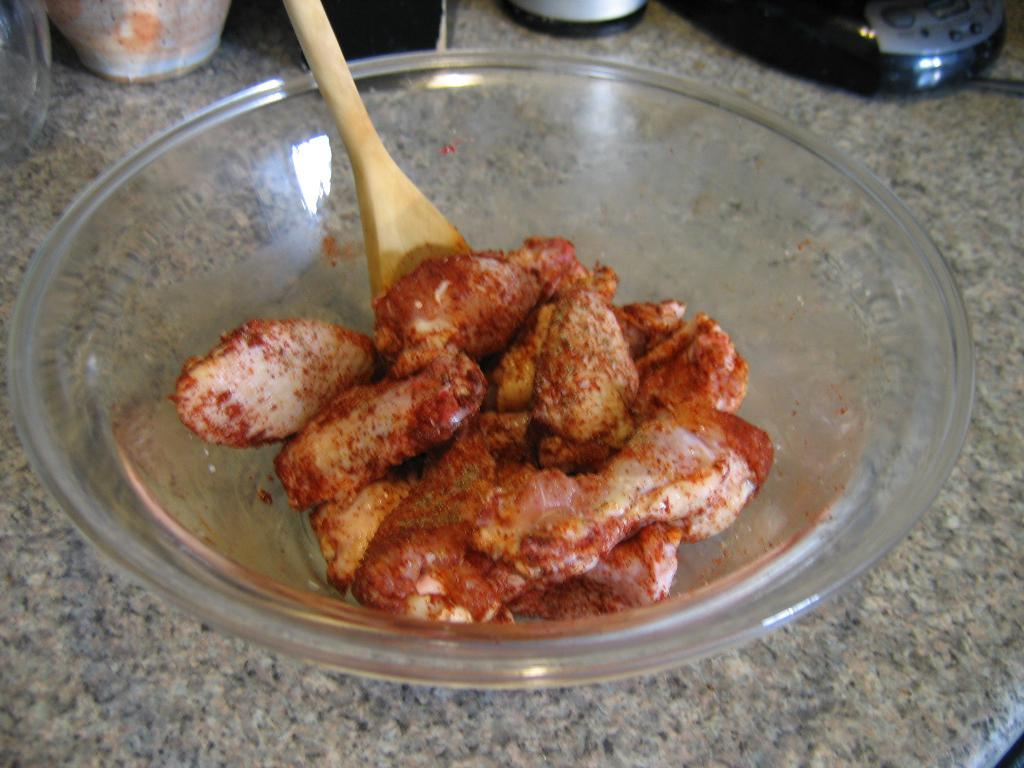What is the main object in the image? There is a ball with meat pieces in the image. What is inside the ball? Wooden spoons are inside the ball. Can you describe the background of the image? There are utensils on a table in the background of the image. What type of chair is depicted in the image? There is no chair present in the image. What nation is represented by the sheet in the image? There is no sheet present in the image. 